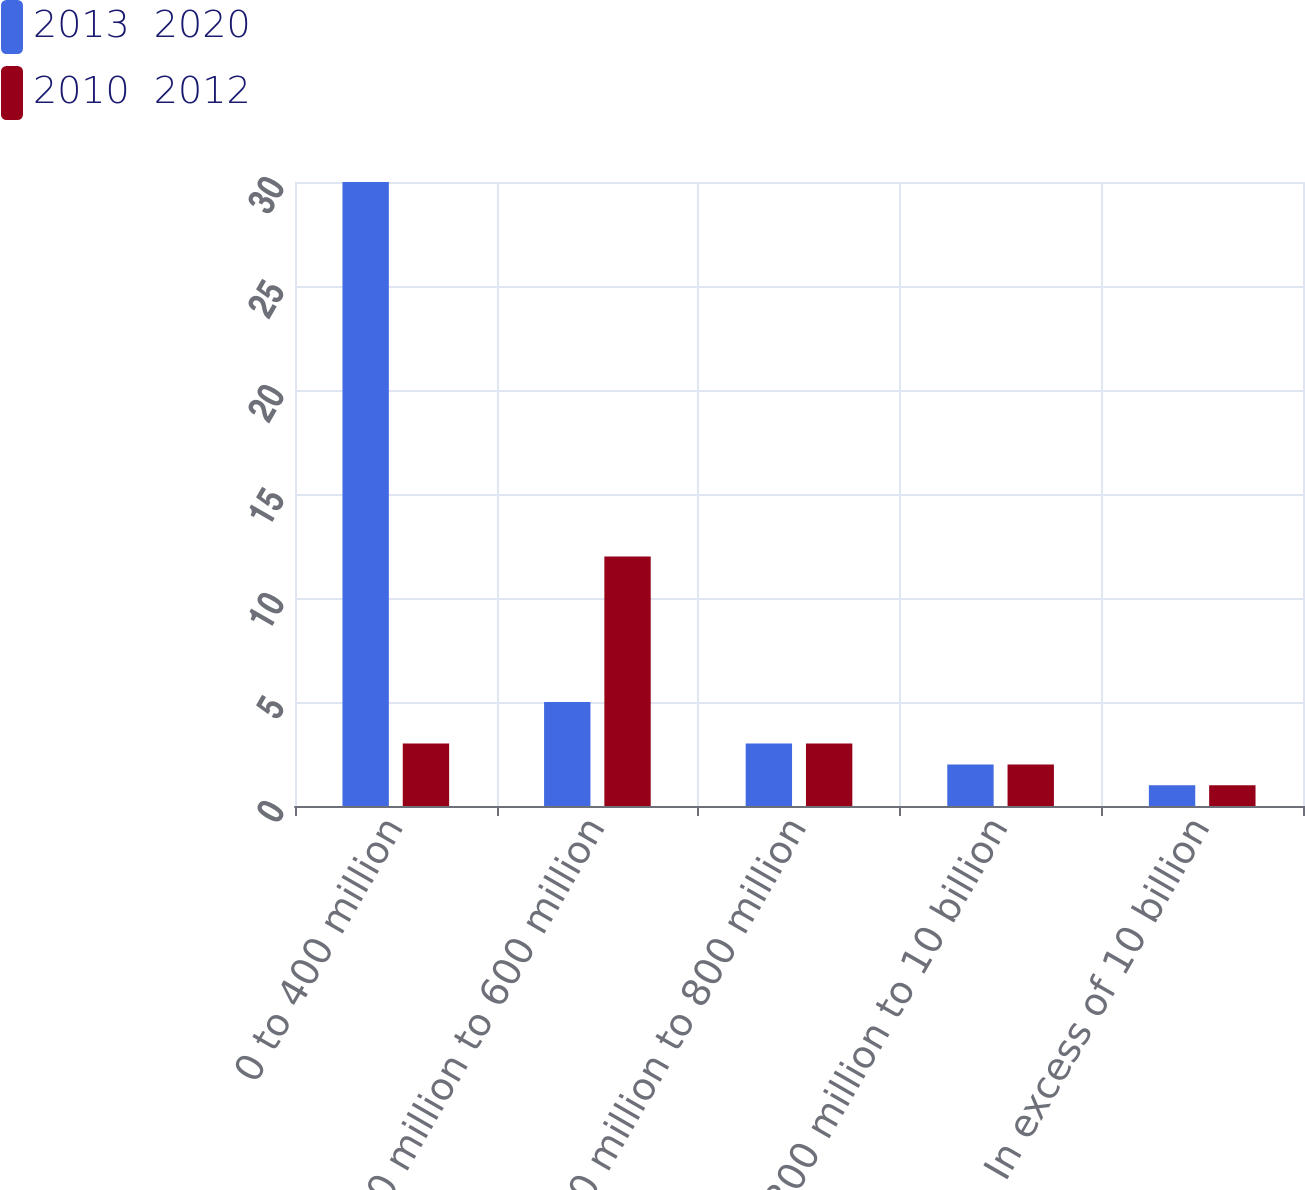<chart> <loc_0><loc_0><loc_500><loc_500><stacked_bar_chart><ecel><fcel>0 to 400 million<fcel>400 million to 600 million<fcel>600 million to 800 million<fcel>800 million to 10 billion<fcel>In excess of 10 billion<nl><fcel>2013  2020<fcel>30<fcel>5<fcel>3<fcel>2<fcel>1<nl><fcel>2010  2012<fcel>3<fcel>12<fcel>3<fcel>2<fcel>1<nl></chart> 